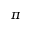Convert formula to latex. <formula><loc_0><loc_0><loc_500><loc_500>\pi</formula> 